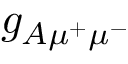<formula> <loc_0><loc_0><loc_500><loc_500>g _ { A \mu ^ { + } \mu ^ { - } }</formula> 